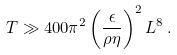<formula> <loc_0><loc_0><loc_500><loc_500>T \gg 4 0 0 \pi ^ { 2 } \left ( \frac { \epsilon } { \rho \eta } \right ) ^ { 2 } L ^ { 8 } \, .</formula> 